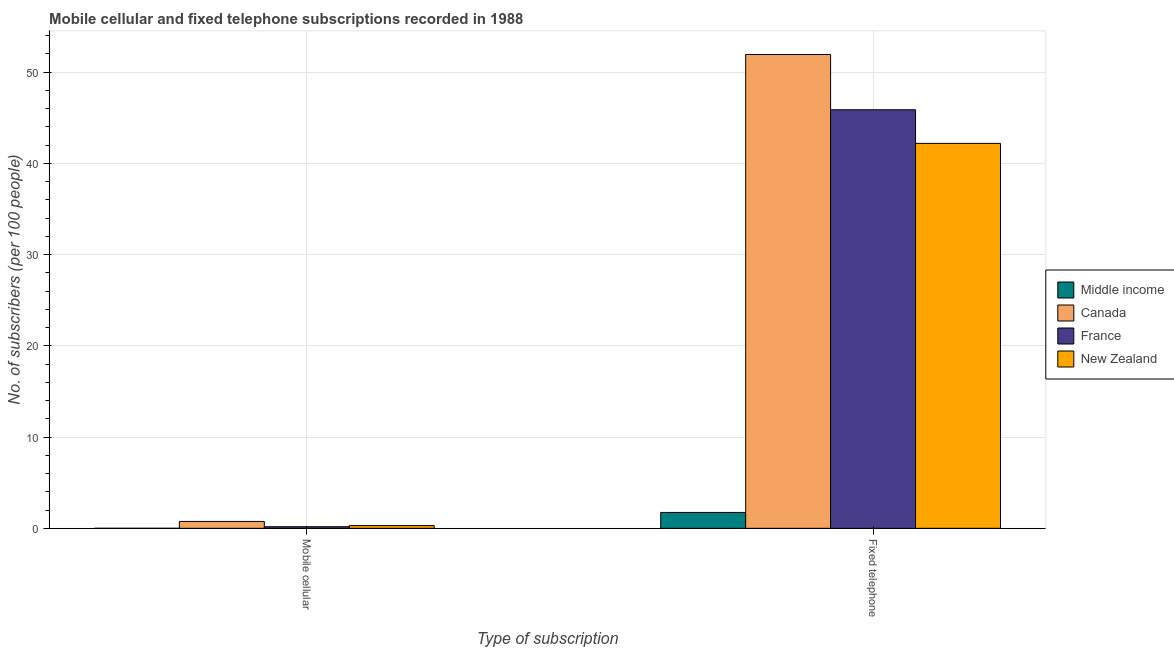How many groups of bars are there?
Make the answer very short. 2. Are the number of bars per tick equal to the number of legend labels?
Make the answer very short. Yes. What is the label of the 1st group of bars from the left?
Give a very brief answer. Mobile cellular. What is the number of fixed telephone subscribers in New Zealand?
Give a very brief answer. 42.19. Across all countries, what is the maximum number of mobile cellular subscribers?
Provide a short and direct response. 0.75. Across all countries, what is the minimum number of mobile cellular subscribers?
Your answer should be compact. 0. In which country was the number of mobile cellular subscribers maximum?
Offer a terse response. Canada. What is the total number of mobile cellular subscribers in the graph?
Give a very brief answer. 1.23. What is the difference between the number of fixed telephone subscribers in Middle income and that in France?
Give a very brief answer. -44.13. What is the difference between the number of mobile cellular subscribers in Canada and the number of fixed telephone subscribers in Middle income?
Provide a succinct answer. -0.99. What is the average number of mobile cellular subscribers per country?
Offer a very short reply. 0.31. What is the difference between the number of fixed telephone subscribers and number of mobile cellular subscribers in Canada?
Ensure brevity in your answer.  51.17. What is the ratio of the number of fixed telephone subscribers in New Zealand to that in France?
Keep it short and to the point. 0.92. Is the number of mobile cellular subscribers in Middle income less than that in New Zealand?
Give a very brief answer. Yes. How many bars are there?
Offer a terse response. 8. Are all the bars in the graph horizontal?
Provide a short and direct response. No. How many countries are there in the graph?
Provide a short and direct response. 4. Does the graph contain any zero values?
Offer a terse response. No. How many legend labels are there?
Your answer should be very brief. 4. What is the title of the graph?
Provide a short and direct response. Mobile cellular and fixed telephone subscriptions recorded in 1988. Does "Egypt, Arab Rep." appear as one of the legend labels in the graph?
Offer a very short reply. No. What is the label or title of the X-axis?
Offer a very short reply. Type of subscription. What is the label or title of the Y-axis?
Offer a terse response. No. of subscribers (per 100 people). What is the No. of subscribers (per 100 people) of Middle income in Mobile cellular?
Your answer should be compact. 0. What is the No. of subscribers (per 100 people) in Canada in Mobile cellular?
Provide a succinct answer. 0.75. What is the No. of subscribers (per 100 people) of France in Mobile cellular?
Make the answer very short. 0.17. What is the No. of subscribers (per 100 people) of New Zealand in Mobile cellular?
Your answer should be very brief. 0.3. What is the No. of subscribers (per 100 people) of Middle income in Fixed telephone?
Provide a succinct answer. 1.74. What is the No. of subscribers (per 100 people) of Canada in Fixed telephone?
Offer a terse response. 51.93. What is the No. of subscribers (per 100 people) of France in Fixed telephone?
Offer a terse response. 45.87. What is the No. of subscribers (per 100 people) of New Zealand in Fixed telephone?
Offer a very short reply. 42.19. Across all Type of subscription, what is the maximum No. of subscribers (per 100 people) in Middle income?
Your answer should be compact. 1.74. Across all Type of subscription, what is the maximum No. of subscribers (per 100 people) in Canada?
Make the answer very short. 51.93. Across all Type of subscription, what is the maximum No. of subscribers (per 100 people) of France?
Keep it short and to the point. 45.87. Across all Type of subscription, what is the maximum No. of subscribers (per 100 people) in New Zealand?
Your answer should be very brief. 42.19. Across all Type of subscription, what is the minimum No. of subscribers (per 100 people) in Middle income?
Provide a succinct answer. 0. Across all Type of subscription, what is the minimum No. of subscribers (per 100 people) of Canada?
Your answer should be compact. 0.75. Across all Type of subscription, what is the minimum No. of subscribers (per 100 people) of France?
Keep it short and to the point. 0.17. Across all Type of subscription, what is the minimum No. of subscribers (per 100 people) of New Zealand?
Offer a very short reply. 0.3. What is the total No. of subscribers (per 100 people) of Middle income in the graph?
Give a very brief answer. 1.74. What is the total No. of subscribers (per 100 people) of Canada in the graph?
Give a very brief answer. 52.68. What is the total No. of subscribers (per 100 people) in France in the graph?
Your answer should be compact. 46.05. What is the total No. of subscribers (per 100 people) of New Zealand in the graph?
Make the answer very short. 42.49. What is the difference between the No. of subscribers (per 100 people) of Middle income in Mobile cellular and that in Fixed telephone?
Keep it short and to the point. -1.74. What is the difference between the No. of subscribers (per 100 people) of Canada in Mobile cellular and that in Fixed telephone?
Provide a succinct answer. -51.17. What is the difference between the No. of subscribers (per 100 people) in France in Mobile cellular and that in Fixed telephone?
Your response must be concise. -45.7. What is the difference between the No. of subscribers (per 100 people) of New Zealand in Mobile cellular and that in Fixed telephone?
Keep it short and to the point. -41.89. What is the difference between the No. of subscribers (per 100 people) in Middle income in Mobile cellular and the No. of subscribers (per 100 people) in Canada in Fixed telephone?
Provide a short and direct response. -51.92. What is the difference between the No. of subscribers (per 100 people) in Middle income in Mobile cellular and the No. of subscribers (per 100 people) in France in Fixed telephone?
Provide a succinct answer. -45.87. What is the difference between the No. of subscribers (per 100 people) in Middle income in Mobile cellular and the No. of subscribers (per 100 people) in New Zealand in Fixed telephone?
Offer a very short reply. -42.18. What is the difference between the No. of subscribers (per 100 people) in Canada in Mobile cellular and the No. of subscribers (per 100 people) in France in Fixed telephone?
Give a very brief answer. -45.12. What is the difference between the No. of subscribers (per 100 people) of Canada in Mobile cellular and the No. of subscribers (per 100 people) of New Zealand in Fixed telephone?
Offer a very short reply. -41.43. What is the difference between the No. of subscribers (per 100 people) in France in Mobile cellular and the No. of subscribers (per 100 people) in New Zealand in Fixed telephone?
Offer a terse response. -42.01. What is the average No. of subscribers (per 100 people) in Middle income per Type of subscription?
Provide a succinct answer. 0.87. What is the average No. of subscribers (per 100 people) in Canada per Type of subscription?
Provide a short and direct response. 26.34. What is the average No. of subscribers (per 100 people) in France per Type of subscription?
Your response must be concise. 23.02. What is the average No. of subscribers (per 100 people) of New Zealand per Type of subscription?
Your answer should be compact. 21.24. What is the difference between the No. of subscribers (per 100 people) in Middle income and No. of subscribers (per 100 people) in Canada in Mobile cellular?
Your answer should be compact. -0.75. What is the difference between the No. of subscribers (per 100 people) in Middle income and No. of subscribers (per 100 people) in France in Mobile cellular?
Provide a succinct answer. -0.17. What is the difference between the No. of subscribers (per 100 people) in Middle income and No. of subscribers (per 100 people) in New Zealand in Mobile cellular?
Your answer should be very brief. -0.3. What is the difference between the No. of subscribers (per 100 people) of Canada and No. of subscribers (per 100 people) of France in Mobile cellular?
Your answer should be very brief. 0.58. What is the difference between the No. of subscribers (per 100 people) in Canada and No. of subscribers (per 100 people) in New Zealand in Mobile cellular?
Provide a short and direct response. 0.45. What is the difference between the No. of subscribers (per 100 people) in France and No. of subscribers (per 100 people) in New Zealand in Mobile cellular?
Make the answer very short. -0.13. What is the difference between the No. of subscribers (per 100 people) in Middle income and No. of subscribers (per 100 people) in Canada in Fixed telephone?
Make the answer very short. -50.19. What is the difference between the No. of subscribers (per 100 people) in Middle income and No. of subscribers (per 100 people) in France in Fixed telephone?
Offer a very short reply. -44.13. What is the difference between the No. of subscribers (per 100 people) of Middle income and No. of subscribers (per 100 people) of New Zealand in Fixed telephone?
Your response must be concise. -40.45. What is the difference between the No. of subscribers (per 100 people) of Canada and No. of subscribers (per 100 people) of France in Fixed telephone?
Your answer should be very brief. 6.05. What is the difference between the No. of subscribers (per 100 people) in Canada and No. of subscribers (per 100 people) in New Zealand in Fixed telephone?
Your response must be concise. 9.74. What is the difference between the No. of subscribers (per 100 people) in France and No. of subscribers (per 100 people) in New Zealand in Fixed telephone?
Provide a succinct answer. 3.69. What is the ratio of the No. of subscribers (per 100 people) of Middle income in Mobile cellular to that in Fixed telephone?
Offer a very short reply. 0. What is the ratio of the No. of subscribers (per 100 people) of Canada in Mobile cellular to that in Fixed telephone?
Provide a short and direct response. 0.01. What is the ratio of the No. of subscribers (per 100 people) of France in Mobile cellular to that in Fixed telephone?
Your answer should be very brief. 0. What is the ratio of the No. of subscribers (per 100 people) of New Zealand in Mobile cellular to that in Fixed telephone?
Your answer should be very brief. 0.01. What is the difference between the highest and the second highest No. of subscribers (per 100 people) of Middle income?
Give a very brief answer. 1.74. What is the difference between the highest and the second highest No. of subscribers (per 100 people) in Canada?
Make the answer very short. 51.17. What is the difference between the highest and the second highest No. of subscribers (per 100 people) in France?
Offer a very short reply. 45.7. What is the difference between the highest and the second highest No. of subscribers (per 100 people) in New Zealand?
Offer a terse response. 41.89. What is the difference between the highest and the lowest No. of subscribers (per 100 people) of Middle income?
Your answer should be compact. 1.74. What is the difference between the highest and the lowest No. of subscribers (per 100 people) of Canada?
Ensure brevity in your answer.  51.17. What is the difference between the highest and the lowest No. of subscribers (per 100 people) of France?
Offer a very short reply. 45.7. What is the difference between the highest and the lowest No. of subscribers (per 100 people) in New Zealand?
Make the answer very short. 41.89. 